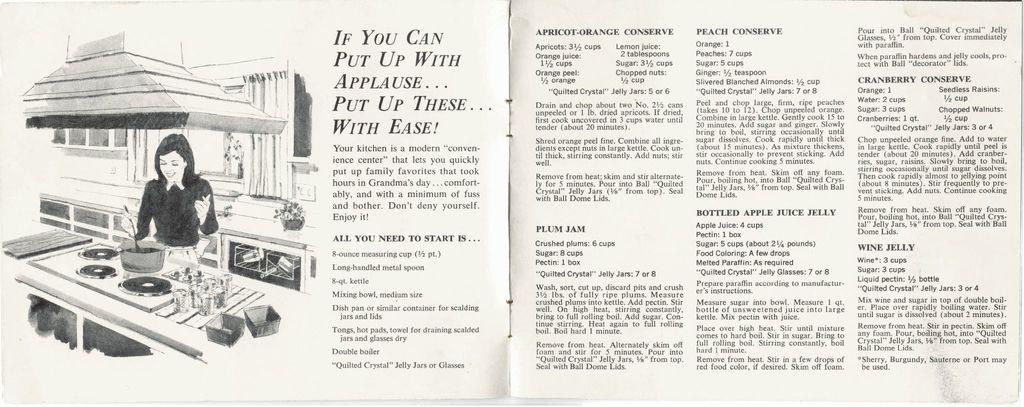What type of object is the image? The image is a book. Can you describe the scene on the left side of the book? There is a girl at a countertop on the left side of the image. What can be found on the right side of the book? There is text on the right side of the image. Can you hear the cat meowing in the image? There is no cat present in the image, so it is not possible to hear any meowing. 